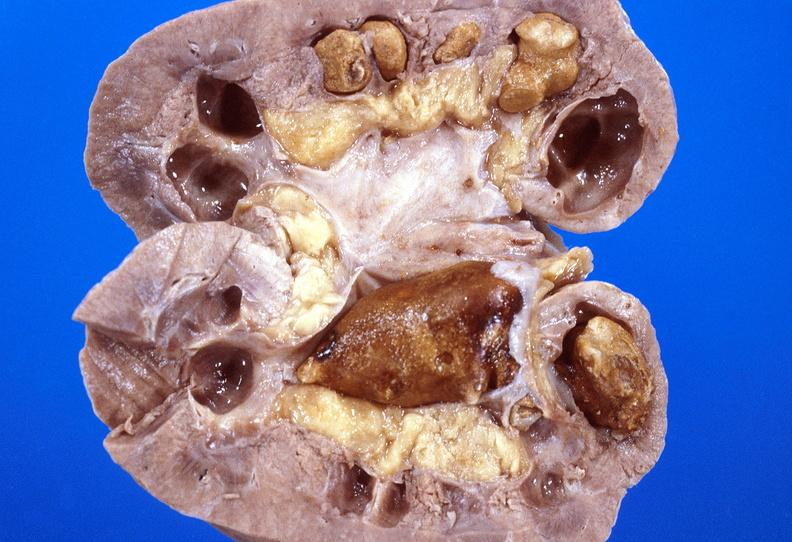does infarcts show kidney, staghorn calculi?
Answer the question using a single word or phrase. No 